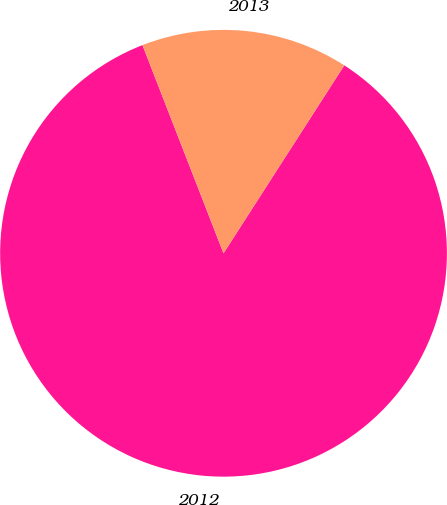<chart> <loc_0><loc_0><loc_500><loc_500><pie_chart><fcel>2012<fcel>2013<nl><fcel>85.0%<fcel>15.0%<nl></chart> 